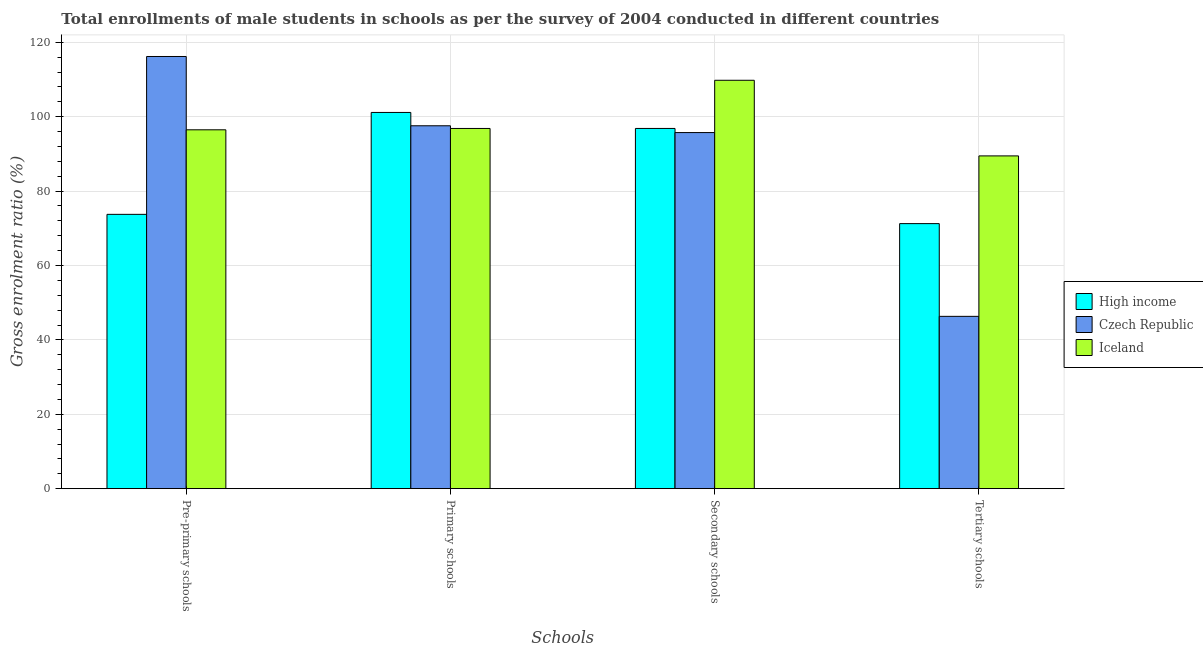How many bars are there on the 4th tick from the left?
Offer a very short reply. 3. What is the label of the 4th group of bars from the left?
Offer a very short reply. Tertiary schools. What is the gross enrolment ratio(male) in tertiary schools in Iceland?
Provide a succinct answer. 89.46. Across all countries, what is the maximum gross enrolment ratio(male) in primary schools?
Your answer should be very brief. 101.14. Across all countries, what is the minimum gross enrolment ratio(male) in pre-primary schools?
Your answer should be very brief. 73.75. In which country was the gross enrolment ratio(male) in tertiary schools maximum?
Offer a terse response. Iceland. In which country was the gross enrolment ratio(male) in tertiary schools minimum?
Your answer should be very brief. Czech Republic. What is the total gross enrolment ratio(male) in primary schools in the graph?
Ensure brevity in your answer.  295.54. What is the difference between the gross enrolment ratio(male) in pre-primary schools in Iceland and that in Czech Republic?
Ensure brevity in your answer.  -19.71. What is the difference between the gross enrolment ratio(male) in tertiary schools in High income and the gross enrolment ratio(male) in pre-primary schools in Czech Republic?
Provide a succinct answer. -44.93. What is the average gross enrolment ratio(male) in tertiary schools per country?
Offer a terse response. 69.02. What is the difference between the gross enrolment ratio(male) in secondary schools and gross enrolment ratio(male) in primary schools in Iceland?
Ensure brevity in your answer.  12.95. What is the ratio of the gross enrolment ratio(male) in pre-primary schools in Czech Republic to that in High income?
Make the answer very short. 1.58. What is the difference between the highest and the second highest gross enrolment ratio(male) in pre-primary schools?
Provide a short and direct response. 19.71. What is the difference between the highest and the lowest gross enrolment ratio(male) in primary schools?
Provide a succinct answer. 4.31. Is the sum of the gross enrolment ratio(male) in secondary schools in High income and Czech Republic greater than the maximum gross enrolment ratio(male) in primary schools across all countries?
Keep it short and to the point. Yes. What does the 2nd bar from the left in Tertiary schools represents?
Your answer should be very brief. Czech Republic. How many bars are there?
Provide a succinct answer. 12. Are the values on the major ticks of Y-axis written in scientific E-notation?
Offer a terse response. No. Does the graph contain any zero values?
Provide a succinct answer. No. Does the graph contain grids?
Keep it short and to the point. Yes. What is the title of the graph?
Your response must be concise. Total enrollments of male students in schools as per the survey of 2004 conducted in different countries. Does "East Asia (developing only)" appear as one of the legend labels in the graph?
Your answer should be very brief. No. What is the label or title of the X-axis?
Your answer should be very brief. Schools. What is the label or title of the Y-axis?
Provide a short and direct response. Gross enrolment ratio (%). What is the Gross enrolment ratio (%) of High income in Pre-primary schools?
Offer a very short reply. 73.75. What is the Gross enrolment ratio (%) of Czech Republic in Pre-primary schools?
Your response must be concise. 116.19. What is the Gross enrolment ratio (%) in Iceland in Pre-primary schools?
Give a very brief answer. 96.48. What is the Gross enrolment ratio (%) of High income in Primary schools?
Provide a short and direct response. 101.14. What is the Gross enrolment ratio (%) of Czech Republic in Primary schools?
Make the answer very short. 97.56. What is the Gross enrolment ratio (%) of Iceland in Primary schools?
Provide a succinct answer. 96.84. What is the Gross enrolment ratio (%) in High income in Secondary schools?
Give a very brief answer. 96.84. What is the Gross enrolment ratio (%) in Czech Republic in Secondary schools?
Keep it short and to the point. 95.73. What is the Gross enrolment ratio (%) of Iceland in Secondary schools?
Make the answer very short. 109.79. What is the Gross enrolment ratio (%) in High income in Tertiary schools?
Your response must be concise. 71.26. What is the Gross enrolment ratio (%) in Czech Republic in Tertiary schools?
Your answer should be very brief. 46.33. What is the Gross enrolment ratio (%) in Iceland in Tertiary schools?
Offer a very short reply. 89.46. Across all Schools, what is the maximum Gross enrolment ratio (%) in High income?
Provide a succinct answer. 101.14. Across all Schools, what is the maximum Gross enrolment ratio (%) of Czech Republic?
Provide a short and direct response. 116.19. Across all Schools, what is the maximum Gross enrolment ratio (%) in Iceland?
Your answer should be compact. 109.79. Across all Schools, what is the minimum Gross enrolment ratio (%) in High income?
Give a very brief answer. 71.26. Across all Schools, what is the minimum Gross enrolment ratio (%) of Czech Republic?
Offer a terse response. 46.33. Across all Schools, what is the minimum Gross enrolment ratio (%) in Iceland?
Your answer should be compact. 89.46. What is the total Gross enrolment ratio (%) of High income in the graph?
Provide a short and direct response. 342.99. What is the total Gross enrolment ratio (%) in Czech Republic in the graph?
Provide a succinct answer. 355.81. What is the total Gross enrolment ratio (%) in Iceland in the graph?
Offer a very short reply. 392.57. What is the difference between the Gross enrolment ratio (%) in High income in Pre-primary schools and that in Primary schools?
Provide a short and direct response. -27.39. What is the difference between the Gross enrolment ratio (%) of Czech Republic in Pre-primary schools and that in Primary schools?
Make the answer very short. 18.63. What is the difference between the Gross enrolment ratio (%) of Iceland in Pre-primary schools and that in Primary schools?
Your response must be concise. -0.36. What is the difference between the Gross enrolment ratio (%) of High income in Pre-primary schools and that in Secondary schools?
Provide a short and direct response. -23.09. What is the difference between the Gross enrolment ratio (%) of Czech Republic in Pre-primary schools and that in Secondary schools?
Offer a very short reply. 20.46. What is the difference between the Gross enrolment ratio (%) of Iceland in Pre-primary schools and that in Secondary schools?
Keep it short and to the point. -13.31. What is the difference between the Gross enrolment ratio (%) of High income in Pre-primary schools and that in Tertiary schools?
Your response must be concise. 2.49. What is the difference between the Gross enrolment ratio (%) in Czech Republic in Pre-primary schools and that in Tertiary schools?
Your answer should be very brief. 69.86. What is the difference between the Gross enrolment ratio (%) in Iceland in Pre-primary schools and that in Tertiary schools?
Keep it short and to the point. 7.02. What is the difference between the Gross enrolment ratio (%) in High income in Primary schools and that in Secondary schools?
Provide a succinct answer. 4.3. What is the difference between the Gross enrolment ratio (%) in Czech Republic in Primary schools and that in Secondary schools?
Offer a very short reply. 1.83. What is the difference between the Gross enrolment ratio (%) of Iceland in Primary schools and that in Secondary schools?
Ensure brevity in your answer.  -12.95. What is the difference between the Gross enrolment ratio (%) of High income in Primary schools and that in Tertiary schools?
Provide a short and direct response. 29.89. What is the difference between the Gross enrolment ratio (%) of Czech Republic in Primary schools and that in Tertiary schools?
Offer a terse response. 51.23. What is the difference between the Gross enrolment ratio (%) of Iceland in Primary schools and that in Tertiary schools?
Ensure brevity in your answer.  7.38. What is the difference between the Gross enrolment ratio (%) of High income in Secondary schools and that in Tertiary schools?
Ensure brevity in your answer.  25.58. What is the difference between the Gross enrolment ratio (%) in Czech Republic in Secondary schools and that in Tertiary schools?
Provide a succinct answer. 49.4. What is the difference between the Gross enrolment ratio (%) in Iceland in Secondary schools and that in Tertiary schools?
Give a very brief answer. 20.33. What is the difference between the Gross enrolment ratio (%) of High income in Pre-primary schools and the Gross enrolment ratio (%) of Czech Republic in Primary schools?
Offer a very short reply. -23.81. What is the difference between the Gross enrolment ratio (%) in High income in Pre-primary schools and the Gross enrolment ratio (%) in Iceland in Primary schools?
Offer a terse response. -23.09. What is the difference between the Gross enrolment ratio (%) of Czech Republic in Pre-primary schools and the Gross enrolment ratio (%) of Iceland in Primary schools?
Your response must be concise. 19.35. What is the difference between the Gross enrolment ratio (%) in High income in Pre-primary schools and the Gross enrolment ratio (%) in Czech Republic in Secondary schools?
Provide a short and direct response. -21.98. What is the difference between the Gross enrolment ratio (%) in High income in Pre-primary schools and the Gross enrolment ratio (%) in Iceland in Secondary schools?
Ensure brevity in your answer.  -36.04. What is the difference between the Gross enrolment ratio (%) in Czech Republic in Pre-primary schools and the Gross enrolment ratio (%) in Iceland in Secondary schools?
Your response must be concise. 6.4. What is the difference between the Gross enrolment ratio (%) of High income in Pre-primary schools and the Gross enrolment ratio (%) of Czech Republic in Tertiary schools?
Your answer should be very brief. 27.42. What is the difference between the Gross enrolment ratio (%) of High income in Pre-primary schools and the Gross enrolment ratio (%) of Iceland in Tertiary schools?
Keep it short and to the point. -15.71. What is the difference between the Gross enrolment ratio (%) in Czech Republic in Pre-primary schools and the Gross enrolment ratio (%) in Iceland in Tertiary schools?
Offer a terse response. 26.73. What is the difference between the Gross enrolment ratio (%) of High income in Primary schools and the Gross enrolment ratio (%) of Czech Republic in Secondary schools?
Provide a succinct answer. 5.41. What is the difference between the Gross enrolment ratio (%) in High income in Primary schools and the Gross enrolment ratio (%) in Iceland in Secondary schools?
Keep it short and to the point. -8.65. What is the difference between the Gross enrolment ratio (%) in Czech Republic in Primary schools and the Gross enrolment ratio (%) in Iceland in Secondary schools?
Provide a succinct answer. -12.23. What is the difference between the Gross enrolment ratio (%) of High income in Primary schools and the Gross enrolment ratio (%) of Czech Republic in Tertiary schools?
Offer a very short reply. 54.82. What is the difference between the Gross enrolment ratio (%) in High income in Primary schools and the Gross enrolment ratio (%) in Iceland in Tertiary schools?
Your response must be concise. 11.68. What is the difference between the Gross enrolment ratio (%) of Czech Republic in Primary schools and the Gross enrolment ratio (%) of Iceland in Tertiary schools?
Ensure brevity in your answer.  8.1. What is the difference between the Gross enrolment ratio (%) of High income in Secondary schools and the Gross enrolment ratio (%) of Czech Republic in Tertiary schools?
Ensure brevity in your answer.  50.51. What is the difference between the Gross enrolment ratio (%) in High income in Secondary schools and the Gross enrolment ratio (%) in Iceland in Tertiary schools?
Offer a terse response. 7.38. What is the difference between the Gross enrolment ratio (%) in Czech Republic in Secondary schools and the Gross enrolment ratio (%) in Iceland in Tertiary schools?
Make the answer very short. 6.27. What is the average Gross enrolment ratio (%) in High income per Schools?
Provide a short and direct response. 85.75. What is the average Gross enrolment ratio (%) in Czech Republic per Schools?
Your response must be concise. 88.95. What is the average Gross enrolment ratio (%) of Iceland per Schools?
Your response must be concise. 98.14. What is the difference between the Gross enrolment ratio (%) of High income and Gross enrolment ratio (%) of Czech Republic in Pre-primary schools?
Keep it short and to the point. -42.44. What is the difference between the Gross enrolment ratio (%) in High income and Gross enrolment ratio (%) in Iceland in Pre-primary schools?
Keep it short and to the point. -22.73. What is the difference between the Gross enrolment ratio (%) of Czech Republic and Gross enrolment ratio (%) of Iceland in Pre-primary schools?
Keep it short and to the point. 19.71. What is the difference between the Gross enrolment ratio (%) of High income and Gross enrolment ratio (%) of Czech Republic in Primary schools?
Give a very brief answer. 3.58. What is the difference between the Gross enrolment ratio (%) in High income and Gross enrolment ratio (%) in Iceland in Primary schools?
Offer a terse response. 4.3. What is the difference between the Gross enrolment ratio (%) of Czech Republic and Gross enrolment ratio (%) of Iceland in Primary schools?
Your answer should be very brief. 0.72. What is the difference between the Gross enrolment ratio (%) of High income and Gross enrolment ratio (%) of Czech Republic in Secondary schools?
Ensure brevity in your answer.  1.11. What is the difference between the Gross enrolment ratio (%) of High income and Gross enrolment ratio (%) of Iceland in Secondary schools?
Offer a terse response. -12.95. What is the difference between the Gross enrolment ratio (%) in Czech Republic and Gross enrolment ratio (%) in Iceland in Secondary schools?
Offer a very short reply. -14.06. What is the difference between the Gross enrolment ratio (%) of High income and Gross enrolment ratio (%) of Czech Republic in Tertiary schools?
Give a very brief answer. 24.93. What is the difference between the Gross enrolment ratio (%) of High income and Gross enrolment ratio (%) of Iceland in Tertiary schools?
Your answer should be compact. -18.2. What is the difference between the Gross enrolment ratio (%) in Czech Republic and Gross enrolment ratio (%) in Iceland in Tertiary schools?
Offer a very short reply. -43.13. What is the ratio of the Gross enrolment ratio (%) in High income in Pre-primary schools to that in Primary schools?
Make the answer very short. 0.73. What is the ratio of the Gross enrolment ratio (%) of Czech Republic in Pre-primary schools to that in Primary schools?
Your answer should be compact. 1.19. What is the ratio of the Gross enrolment ratio (%) in High income in Pre-primary schools to that in Secondary schools?
Ensure brevity in your answer.  0.76. What is the ratio of the Gross enrolment ratio (%) in Czech Republic in Pre-primary schools to that in Secondary schools?
Give a very brief answer. 1.21. What is the ratio of the Gross enrolment ratio (%) in Iceland in Pre-primary schools to that in Secondary schools?
Your answer should be very brief. 0.88. What is the ratio of the Gross enrolment ratio (%) in High income in Pre-primary schools to that in Tertiary schools?
Offer a terse response. 1.03. What is the ratio of the Gross enrolment ratio (%) of Czech Republic in Pre-primary schools to that in Tertiary schools?
Keep it short and to the point. 2.51. What is the ratio of the Gross enrolment ratio (%) of Iceland in Pre-primary schools to that in Tertiary schools?
Ensure brevity in your answer.  1.08. What is the ratio of the Gross enrolment ratio (%) of High income in Primary schools to that in Secondary schools?
Your answer should be compact. 1.04. What is the ratio of the Gross enrolment ratio (%) in Czech Republic in Primary schools to that in Secondary schools?
Make the answer very short. 1.02. What is the ratio of the Gross enrolment ratio (%) of Iceland in Primary schools to that in Secondary schools?
Your response must be concise. 0.88. What is the ratio of the Gross enrolment ratio (%) in High income in Primary schools to that in Tertiary schools?
Provide a short and direct response. 1.42. What is the ratio of the Gross enrolment ratio (%) of Czech Republic in Primary schools to that in Tertiary schools?
Offer a terse response. 2.11. What is the ratio of the Gross enrolment ratio (%) in Iceland in Primary schools to that in Tertiary schools?
Ensure brevity in your answer.  1.08. What is the ratio of the Gross enrolment ratio (%) in High income in Secondary schools to that in Tertiary schools?
Keep it short and to the point. 1.36. What is the ratio of the Gross enrolment ratio (%) in Czech Republic in Secondary schools to that in Tertiary schools?
Your answer should be very brief. 2.07. What is the ratio of the Gross enrolment ratio (%) of Iceland in Secondary schools to that in Tertiary schools?
Offer a very short reply. 1.23. What is the difference between the highest and the second highest Gross enrolment ratio (%) of High income?
Offer a very short reply. 4.3. What is the difference between the highest and the second highest Gross enrolment ratio (%) of Czech Republic?
Your response must be concise. 18.63. What is the difference between the highest and the second highest Gross enrolment ratio (%) in Iceland?
Your answer should be very brief. 12.95. What is the difference between the highest and the lowest Gross enrolment ratio (%) in High income?
Ensure brevity in your answer.  29.89. What is the difference between the highest and the lowest Gross enrolment ratio (%) in Czech Republic?
Your response must be concise. 69.86. What is the difference between the highest and the lowest Gross enrolment ratio (%) in Iceland?
Your answer should be very brief. 20.33. 